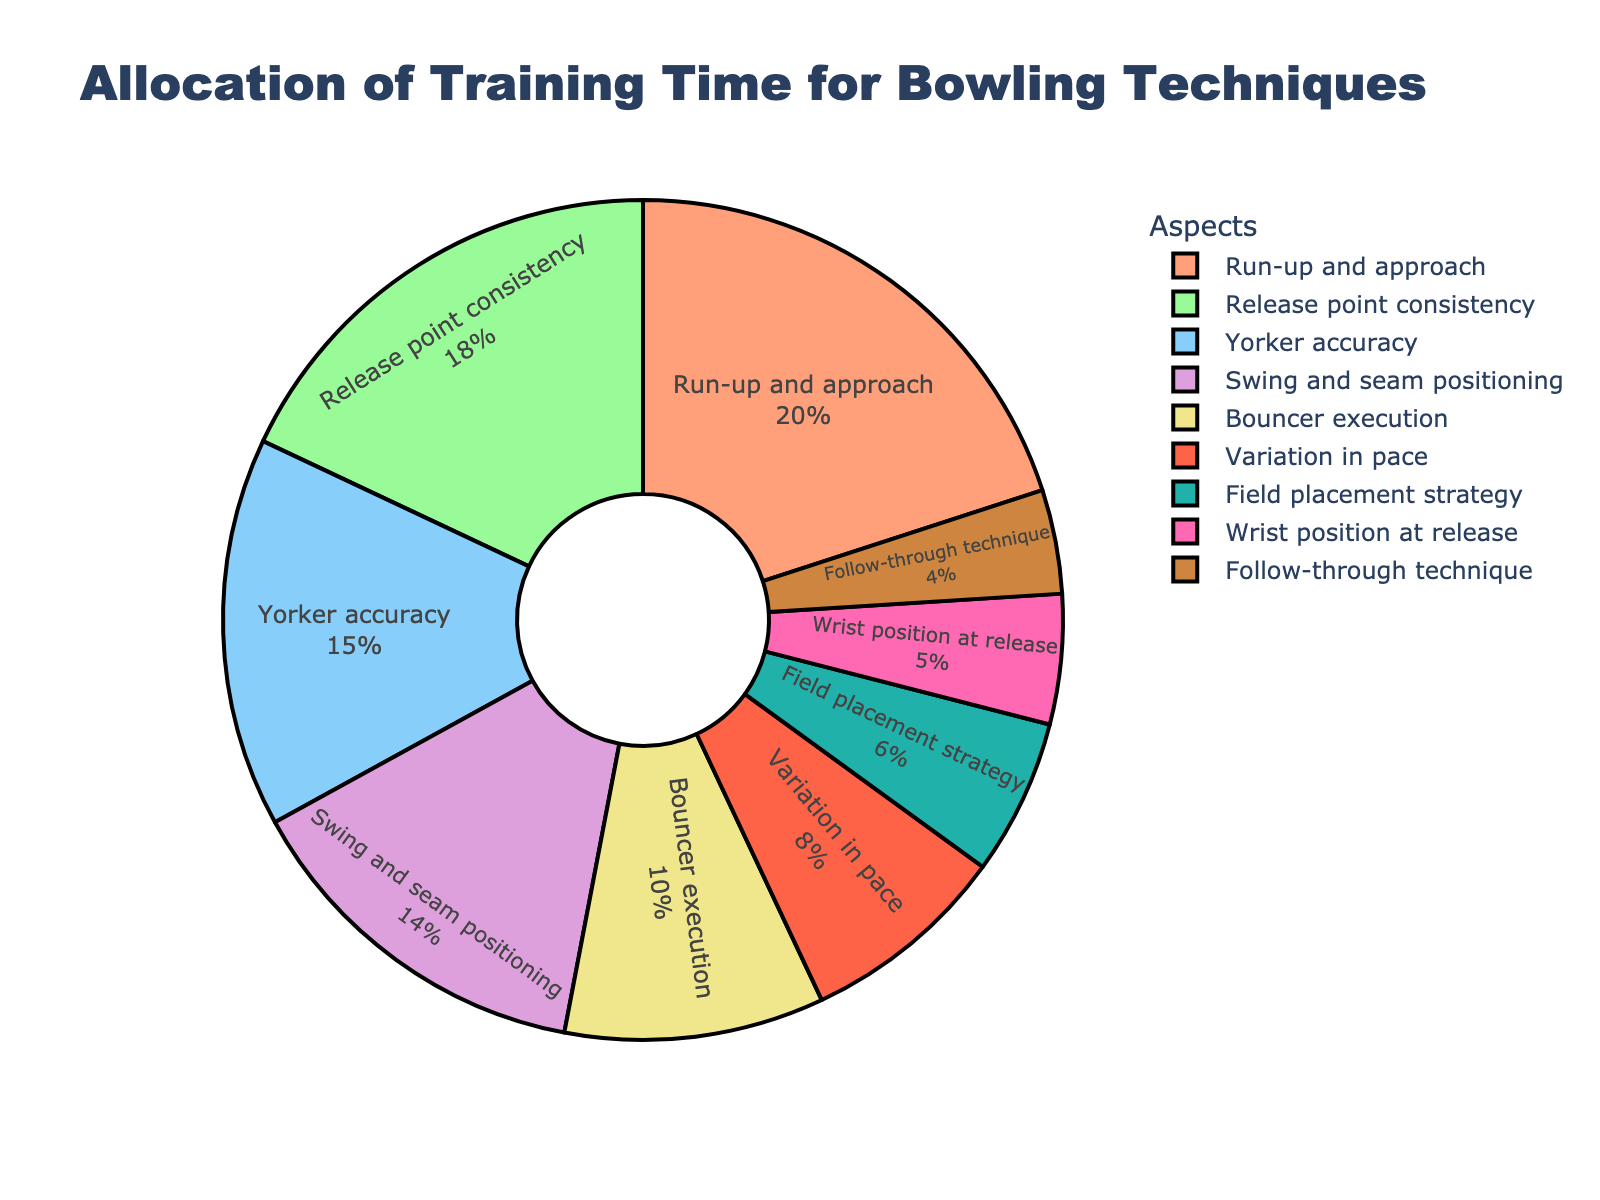What's the most allocated aspect of training time? To find the most allocated aspect, look at the aspect with the highest percentage in the pie chart. “Run-up and approach” has 20%, which is the highest.
Answer: Run-up and approach Which two aspects together account for 33% of the training time? Adding the percentages of two aspects to see if they sum to 33%. “Swing and seam positioning” (14%) + “Variation in pace” (8%) = 22%, and “Swing and seam positioning” (14%) + “Wrist position at release” (5%) = 19%, but “Release point consistency” (18%) + “Yorker accuracy” (15%) = 33%.
Answer: Release point consistency and Yorker accuracy What is the difference in allocated training time between the aspect with the least and the most allocation? The aspect with the least allocation is “Follow-through technique” (4%) and the most is “Run-up and approach” (20%). The difference is 20% - 4% = 16%.
Answer: 16% Which aspects account for less than 10% each? Identify the slices of the pie chart with percentages less than 10%. “Variation in pace” (8%), “Field placement strategy” (6%), “Wrist position at release” (5%), and “Follow-through technique” (4%) fit this criterion.
Answer: Variation in pace, Field placement strategy, Wrist position at release, Follow-through technique What is the total percentage of the top three training time allocations? Sum the top three percentages: “Run-up and approach” (20%), “Release point consistency” (18%), and “Yorker accuracy” (15%). 20% + 18% + 15% = 53%.
Answer: 53% Is the time allocated to ‘Bouncer execution’ greater than ‘Variation in pace’? Compare the percentages directly: “Bouncer execution” (10%) vs. “Variation in pace” (8%). 10% > 8%, hence ‘Bouncer execution’ has more allocation.
Answer: Yes What percentage of training time is allocated to aspects focusing on the bowler's arm mechanics (release point consistency, wrist position at release, and follow-through technique)? Sum the relevant percentages: “Release point consistency” (18%), “Wrist position at release” (5%), and “Follow-through technique” (4%). 18% + 5% + 4% = 27%.
Answer: 27% If you are advised to cut training time equally among the top four aspects to a total of 40%, how much time would each aspect get? Sum the top four percentages, calculate the necessary reduction, and divide by four. Total: 20% (Run-up) + 18% (Release) + 15% (Yorker) + 14% (Swing) = 67%. Reduction needed: 67% - 40% = 27%. Each aspect: 27% / 4 = 6.75%. Subtract this from each aspect: 20% - 6.75% = 13.25%, 18% - 6.75% = 11.25%, 15% - 6.75% = 8.25%, and 14% - 6.75% = 7.25%.
Answer: Run-up and approach: 13.25%, Release point consistency: 11.25%, Yorker accuracy: 8.25%, Swing and seam positioning: 7.25% 